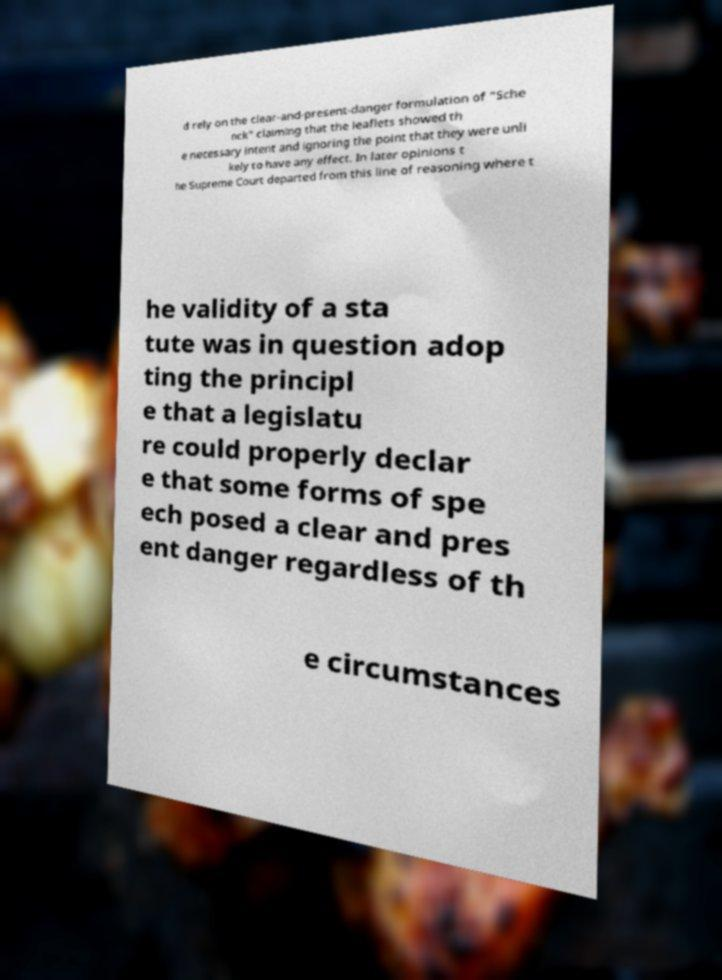Could you extract and type out the text from this image? d rely on the clear-and-present-danger formulation of "Sche nck" claiming that the leaflets showed th e necessary intent and ignoring the point that they were unli kely to have any effect. In later opinions t he Supreme Court departed from this line of reasoning where t he validity of a sta tute was in question adop ting the principl e that a legislatu re could properly declar e that some forms of spe ech posed a clear and pres ent danger regardless of th e circumstances 